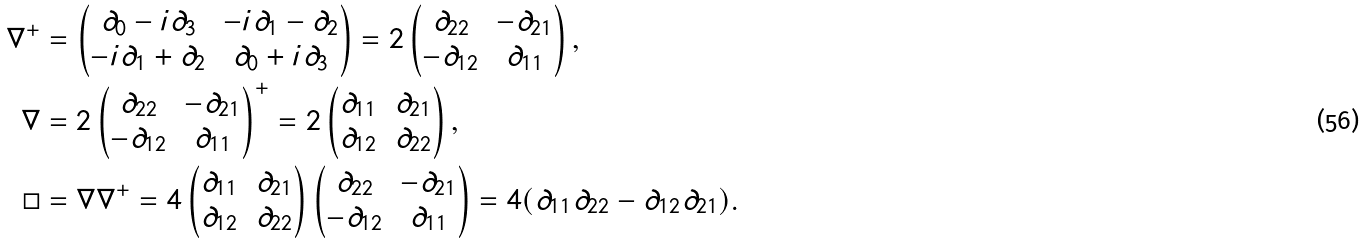Convert formula to latex. <formula><loc_0><loc_0><loc_500><loc_500>\nabla ^ { + } & = \begin{pmatrix} \partial _ { 0 } - i \partial _ { 3 } & - i \partial _ { 1 } - \partial _ { 2 } \\ - i \partial _ { 1 } + \partial _ { 2 } & \partial _ { 0 } + i \partial _ { 3 } \end{pmatrix} = 2 \begin{pmatrix} \partial _ { 2 2 } & - \partial _ { 2 1 } \\ - \partial _ { 1 2 } & \partial _ { 1 1 } \end{pmatrix} , \\ \nabla & = 2 \begin{pmatrix} \partial _ { 2 2 } & - \partial _ { 2 1 } \\ - \partial _ { 1 2 } & \partial _ { 1 1 } \end{pmatrix} ^ { + } = 2 \begin{pmatrix} \partial _ { 1 1 } & \partial _ { 2 1 } \\ \partial _ { 1 2 } & \partial _ { 2 2 } \end{pmatrix} , \\ \square & = \nabla \nabla ^ { + } = 4 \begin{pmatrix} \partial _ { 1 1 } & \partial _ { 2 1 } \\ \partial _ { 1 2 } & \partial _ { 2 2 } \end{pmatrix} \begin{pmatrix} \partial _ { 2 2 } & - \partial _ { 2 1 } \\ - \partial _ { 1 2 } & \partial _ { 1 1 } \end{pmatrix} = 4 ( \partial _ { 1 1 } \partial _ { 2 2 } - \partial _ { 1 2 } \partial _ { 2 1 } ) .</formula> 